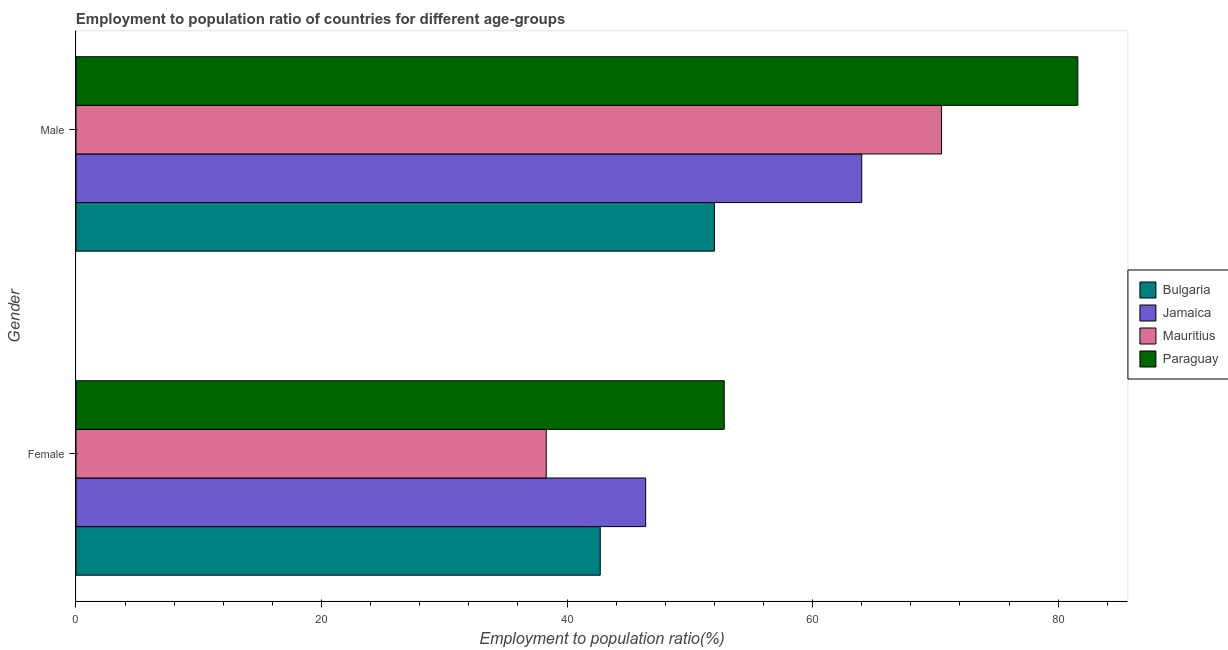How many different coloured bars are there?
Your answer should be compact. 4. How many bars are there on the 2nd tick from the bottom?
Provide a short and direct response. 4. What is the label of the 1st group of bars from the top?
Make the answer very short. Male. What is the employment to population ratio(male) in Jamaica?
Offer a very short reply. 64. Across all countries, what is the maximum employment to population ratio(male)?
Your answer should be very brief. 81.6. Across all countries, what is the minimum employment to population ratio(female)?
Give a very brief answer. 38.3. In which country was the employment to population ratio(female) maximum?
Keep it short and to the point. Paraguay. In which country was the employment to population ratio(female) minimum?
Your response must be concise. Mauritius. What is the total employment to population ratio(female) in the graph?
Your answer should be very brief. 180.2. What is the difference between the employment to population ratio(female) in Bulgaria and that in Jamaica?
Offer a very short reply. -3.7. What is the difference between the employment to population ratio(male) in Paraguay and the employment to population ratio(female) in Bulgaria?
Ensure brevity in your answer.  38.9. What is the average employment to population ratio(male) per country?
Keep it short and to the point. 67.02. What is the difference between the employment to population ratio(female) and employment to population ratio(male) in Jamaica?
Make the answer very short. -17.6. What is the ratio of the employment to population ratio(female) in Jamaica to that in Mauritius?
Provide a short and direct response. 1.21. In how many countries, is the employment to population ratio(female) greater than the average employment to population ratio(female) taken over all countries?
Offer a terse response. 2. What does the 1st bar from the top in Male represents?
Make the answer very short. Paraguay. How many countries are there in the graph?
Provide a succinct answer. 4. What is the difference between two consecutive major ticks on the X-axis?
Provide a succinct answer. 20. Does the graph contain any zero values?
Offer a very short reply. No. How many legend labels are there?
Give a very brief answer. 4. What is the title of the graph?
Make the answer very short. Employment to population ratio of countries for different age-groups. What is the label or title of the Y-axis?
Offer a terse response. Gender. What is the Employment to population ratio(%) in Bulgaria in Female?
Your response must be concise. 42.7. What is the Employment to population ratio(%) of Jamaica in Female?
Make the answer very short. 46.4. What is the Employment to population ratio(%) of Mauritius in Female?
Your response must be concise. 38.3. What is the Employment to population ratio(%) in Paraguay in Female?
Offer a terse response. 52.8. What is the Employment to population ratio(%) in Bulgaria in Male?
Make the answer very short. 52. What is the Employment to population ratio(%) of Mauritius in Male?
Give a very brief answer. 70.5. What is the Employment to population ratio(%) in Paraguay in Male?
Provide a succinct answer. 81.6. Across all Gender, what is the maximum Employment to population ratio(%) of Mauritius?
Your response must be concise. 70.5. Across all Gender, what is the maximum Employment to population ratio(%) in Paraguay?
Your response must be concise. 81.6. Across all Gender, what is the minimum Employment to population ratio(%) of Bulgaria?
Provide a short and direct response. 42.7. Across all Gender, what is the minimum Employment to population ratio(%) of Jamaica?
Your response must be concise. 46.4. Across all Gender, what is the minimum Employment to population ratio(%) of Mauritius?
Provide a succinct answer. 38.3. Across all Gender, what is the minimum Employment to population ratio(%) in Paraguay?
Make the answer very short. 52.8. What is the total Employment to population ratio(%) of Bulgaria in the graph?
Ensure brevity in your answer.  94.7. What is the total Employment to population ratio(%) of Jamaica in the graph?
Offer a very short reply. 110.4. What is the total Employment to population ratio(%) in Mauritius in the graph?
Offer a terse response. 108.8. What is the total Employment to population ratio(%) of Paraguay in the graph?
Make the answer very short. 134.4. What is the difference between the Employment to population ratio(%) in Jamaica in Female and that in Male?
Your answer should be compact. -17.6. What is the difference between the Employment to population ratio(%) of Mauritius in Female and that in Male?
Keep it short and to the point. -32.2. What is the difference between the Employment to population ratio(%) of Paraguay in Female and that in Male?
Your answer should be very brief. -28.8. What is the difference between the Employment to population ratio(%) of Bulgaria in Female and the Employment to population ratio(%) of Jamaica in Male?
Make the answer very short. -21.3. What is the difference between the Employment to population ratio(%) in Bulgaria in Female and the Employment to population ratio(%) in Mauritius in Male?
Offer a very short reply. -27.8. What is the difference between the Employment to population ratio(%) of Bulgaria in Female and the Employment to population ratio(%) of Paraguay in Male?
Make the answer very short. -38.9. What is the difference between the Employment to population ratio(%) in Jamaica in Female and the Employment to population ratio(%) in Mauritius in Male?
Your response must be concise. -24.1. What is the difference between the Employment to population ratio(%) in Jamaica in Female and the Employment to population ratio(%) in Paraguay in Male?
Your answer should be very brief. -35.2. What is the difference between the Employment to population ratio(%) of Mauritius in Female and the Employment to population ratio(%) of Paraguay in Male?
Make the answer very short. -43.3. What is the average Employment to population ratio(%) of Bulgaria per Gender?
Provide a short and direct response. 47.35. What is the average Employment to population ratio(%) in Jamaica per Gender?
Your answer should be compact. 55.2. What is the average Employment to population ratio(%) of Mauritius per Gender?
Your answer should be very brief. 54.4. What is the average Employment to population ratio(%) of Paraguay per Gender?
Your answer should be compact. 67.2. What is the difference between the Employment to population ratio(%) in Bulgaria and Employment to population ratio(%) in Paraguay in Female?
Ensure brevity in your answer.  -10.1. What is the difference between the Employment to population ratio(%) in Mauritius and Employment to population ratio(%) in Paraguay in Female?
Offer a terse response. -14.5. What is the difference between the Employment to population ratio(%) of Bulgaria and Employment to population ratio(%) of Mauritius in Male?
Give a very brief answer. -18.5. What is the difference between the Employment to population ratio(%) of Bulgaria and Employment to population ratio(%) of Paraguay in Male?
Your answer should be very brief. -29.6. What is the difference between the Employment to population ratio(%) in Jamaica and Employment to population ratio(%) in Mauritius in Male?
Your answer should be very brief. -6.5. What is the difference between the Employment to population ratio(%) in Jamaica and Employment to population ratio(%) in Paraguay in Male?
Make the answer very short. -17.6. What is the ratio of the Employment to population ratio(%) of Bulgaria in Female to that in Male?
Offer a very short reply. 0.82. What is the ratio of the Employment to population ratio(%) in Jamaica in Female to that in Male?
Your answer should be compact. 0.72. What is the ratio of the Employment to population ratio(%) of Mauritius in Female to that in Male?
Provide a short and direct response. 0.54. What is the ratio of the Employment to population ratio(%) in Paraguay in Female to that in Male?
Your answer should be compact. 0.65. What is the difference between the highest and the second highest Employment to population ratio(%) in Bulgaria?
Offer a very short reply. 9.3. What is the difference between the highest and the second highest Employment to population ratio(%) of Jamaica?
Your response must be concise. 17.6. What is the difference between the highest and the second highest Employment to population ratio(%) in Mauritius?
Give a very brief answer. 32.2. What is the difference between the highest and the second highest Employment to population ratio(%) in Paraguay?
Your response must be concise. 28.8. What is the difference between the highest and the lowest Employment to population ratio(%) of Mauritius?
Keep it short and to the point. 32.2. What is the difference between the highest and the lowest Employment to population ratio(%) in Paraguay?
Give a very brief answer. 28.8. 